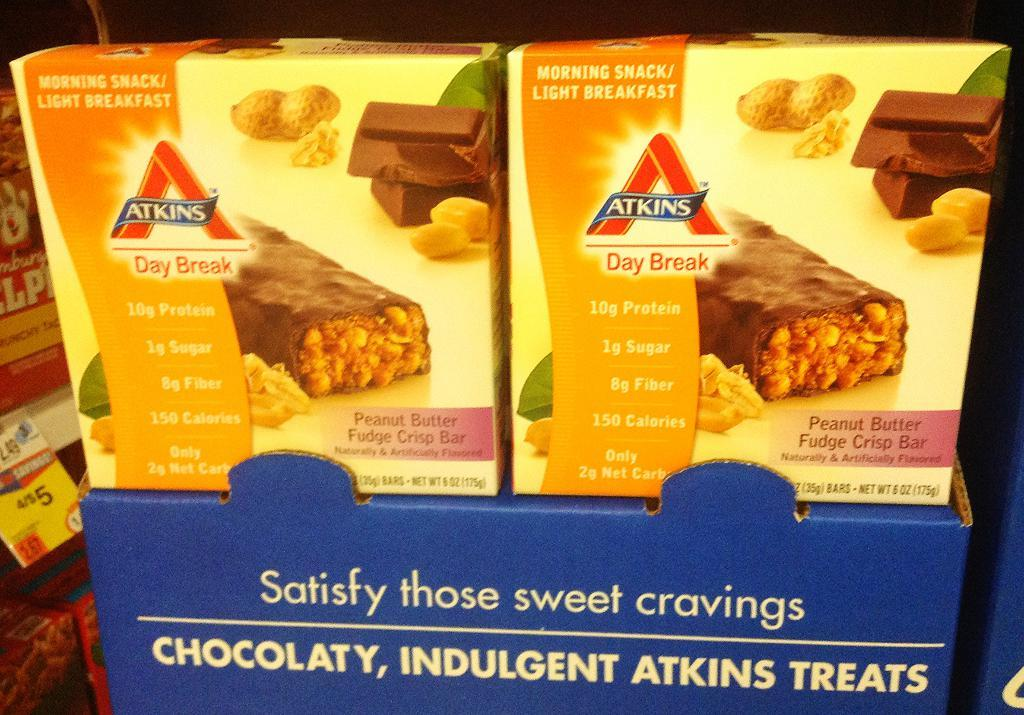What type of product is contained in the boxes in the image? The boxes in the image contain chocolate bars. Where are the chocolate bar boxes placed? The chocolate bar boxes are on a cardboard box. What is written on the chocolate bar boxes? The word "ATKINS" is written on the chocolate bar boxes. What color is the hair on the chocolate bar boxes? There is no hair present on the chocolate bar boxes; they are made of cardboard and have text and images printed on them. 